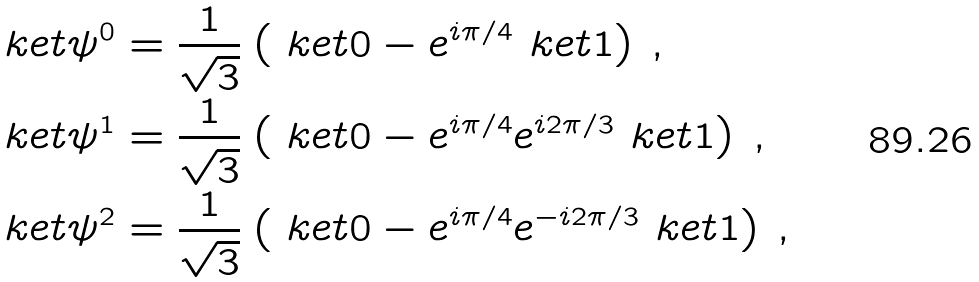Convert formula to latex. <formula><loc_0><loc_0><loc_500><loc_500>\ k e t { \psi ^ { 0 } } & = \frac { 1 } { \sqrt { 3 } } \left ( \ k e t 0 - e ^ { i \pi / 4 } \ k e t 1 \right ) \, , \\ \ k e t { \psi ^ { 1 } } & = \frac { 1 } { \sqrt { 3 } } \left ( \ k e t 0 - e ^ { i \pi / 4 } e ^ { i 2 \pi / 3 } \ k e t 1 \right ) \, , \\ \ k e t { \psi ^ { 2 } } & = \frac { 1 } { \sqrt { 3 } } \left ( \ k e t 0 - e ^ { i \pi / 4 } e ^ { - i 2 \pi / 3 } \ k e t 1 \right ) \, ,</formula> 